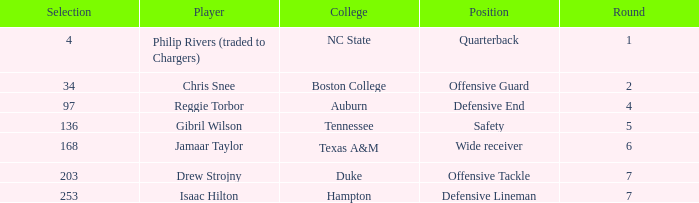Which Selection has a College of texas a&m? 168.0. 